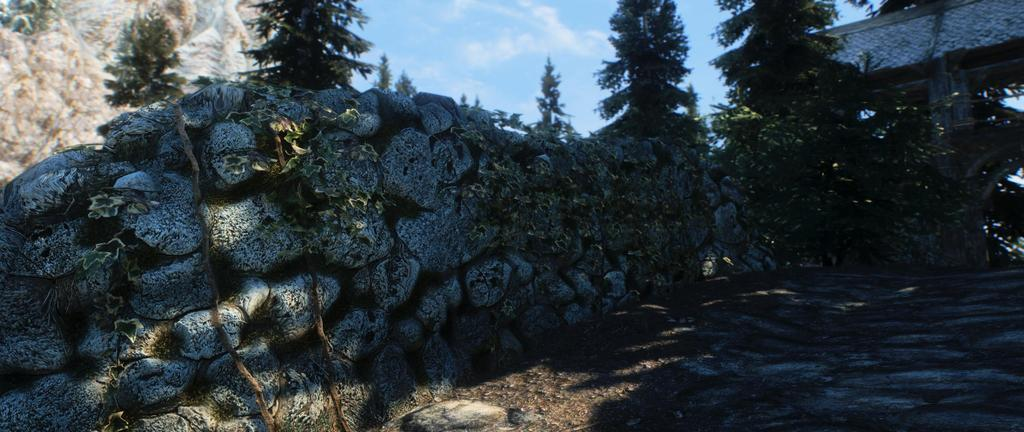What can be seen at the base of the image? The ground is visible in the image. What type of natural elements are present in the image? There are stones and trees in the image. What type of architectural feature can be seen in the image? There is an arch in the image. What is visible in the background of the image? The sky is visible in the background of the image. What atmospheric conditions can be observed in the sky? Clouds are present in the sky. Can you hear the bird singing in the image? There is no bird present in the image, so it is not possible to hear it singing. 